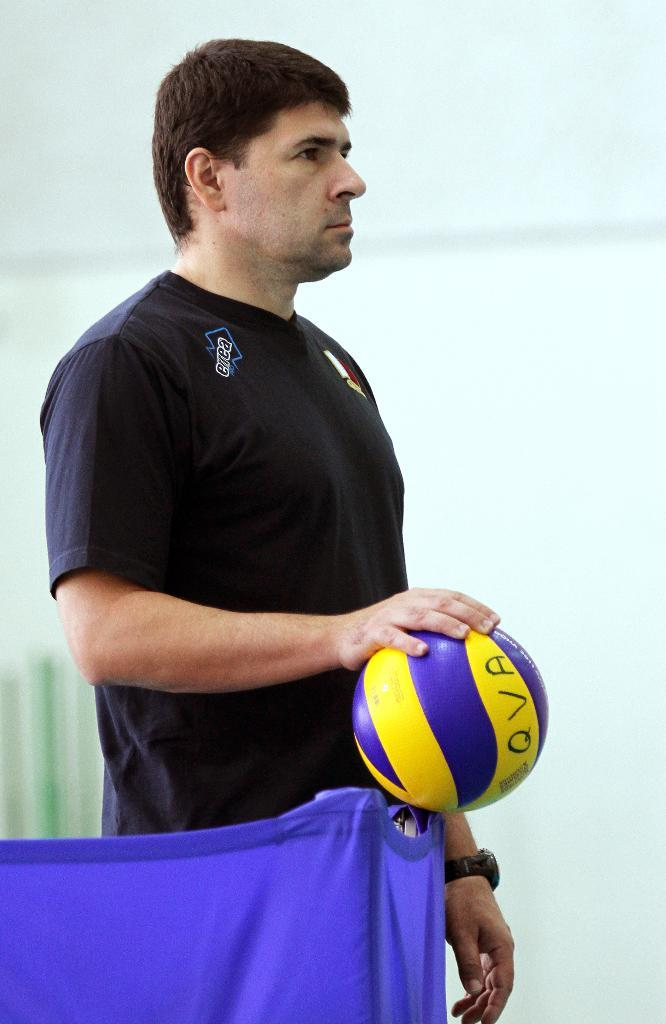What is the man in the image wearing? The man is wearing a t-shirt. What accessory is the man wearing on his wrist? The man is wearing a watch. What object is the man holding in the image? The man is holding a volleyball. Can you describe the bottom left corner of the image? There is a blue cloth in the bottom left of the image. What can be seen in the background of the image? There is a blurred image in the background of the image. What type of garden can be seen in the background of the image? There is no garden present in the image; the background features a blurred image. 